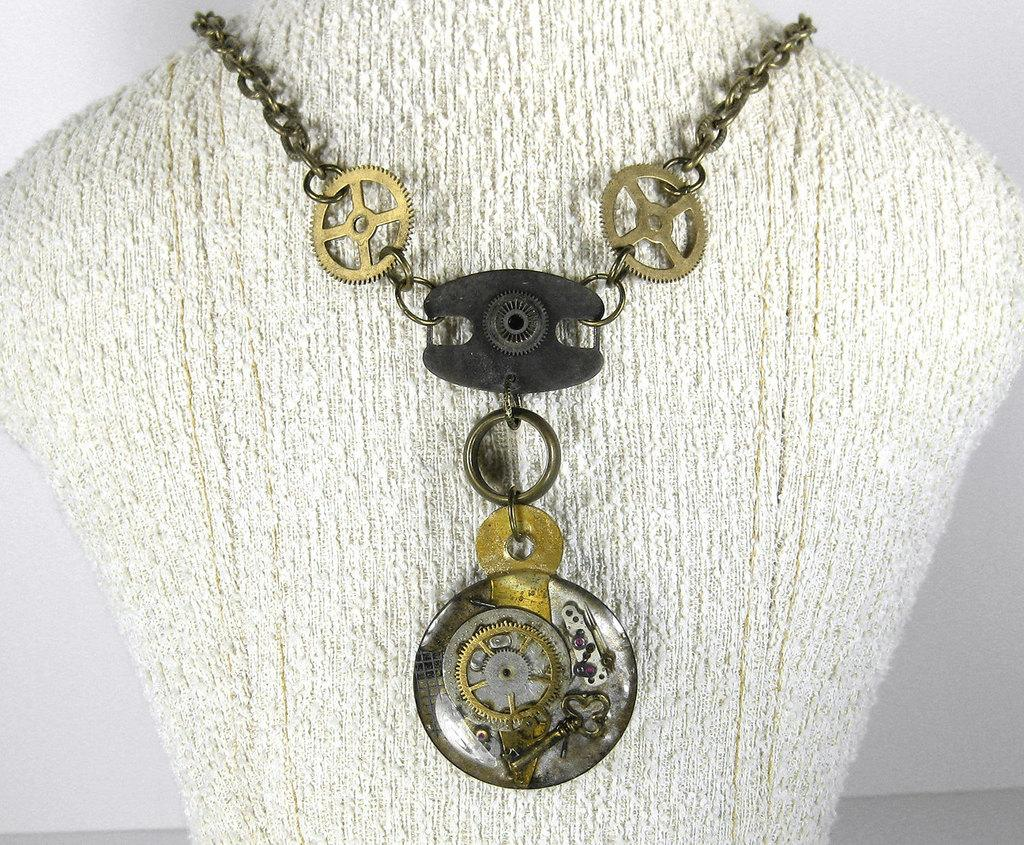What can be seen in the image that resembles a series of connected links? There is a chain in the image. Is there anything connected to the chain? Yes, there is an object attached to the chain. How does the chain contribute to pollution in the image? There is no indication of pollution in the image, and the chain itself does not contribute to pollution. 